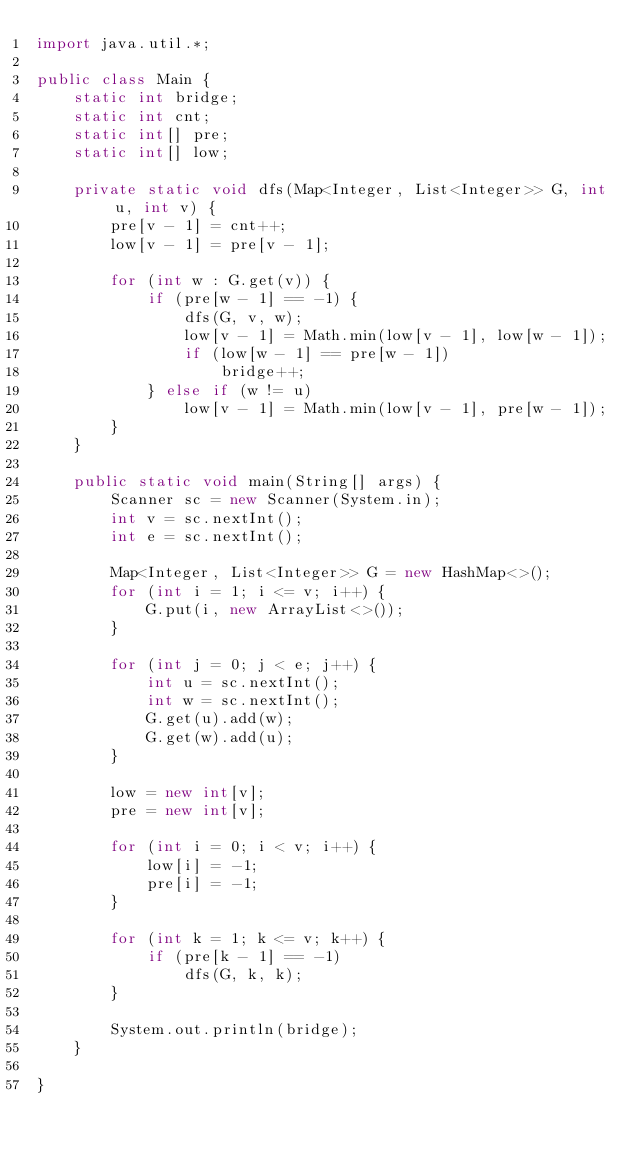Convert code to text. <code><loc_0><loc_0><loc_500><loc_500><_Java_>import java.util.*;

public class Main {
    static int bridge;
    static int cnt;
    static int[] pre;
    static int[] low;

    private static void dfs(Map<Integer, List<Integer>> G, int u, int v) {
        pre[v - 1] = cnt++;
        low[v - 1] = pre[v - 1];

        for (int w : G.get(v)) {
            if (pre[w - 1] == -1) {
                dfs(G, v, w);
                low[v - 1] = Math.min(low[v - 1], low[w - 1]);
                if (low[w - 1] == pre[w - 1])
                    bridge++;
            } else if (w != u)
                low[v - 1] = Math.min(low[v - 1], pre[w - 1]);
        }
    }

    public static void main(String[] args) {
        Scanner sc = new Scanner(System.in);
        int v = sc.nextInt();
        int e = sc.nextInt();

        Map<Integer, List<Integer>> G = new HashMap<>();
        for (int i = 1; i <= v; i++) {
            G.put(i, new ArrayList<>());
        }

        for (int j = 0; j < e; j++) {
            int u = sc.nextInt();
            int w = sc.nextInt();
            G.get(u).add(w);
            G.get(w).add(u);
        }

        low = new int[v];
        pre = new int[v];

        for (int i = 0; i < v; i++) {
            low[i] = -1;
            pre[i] = -1;
        }

        for (int k = 1; k <= v; k++) {
            if (pre[k - 1] == -1)
                dfs(G, k, k);
        }

        System.out.println(bridge);
    }

}</code> 